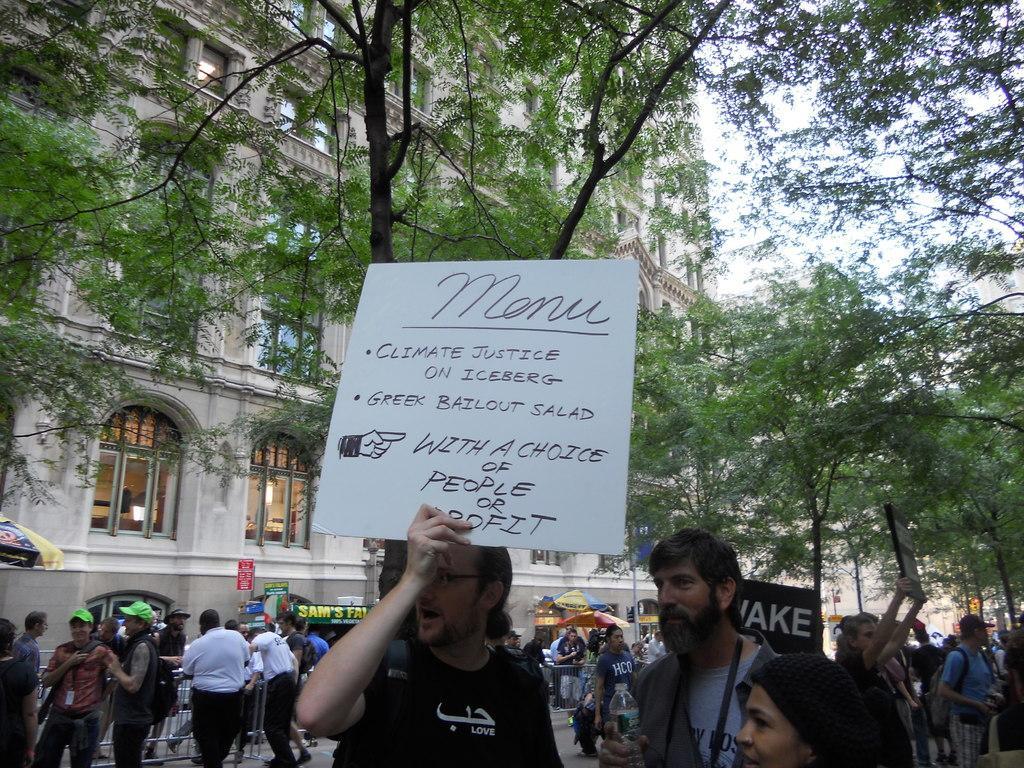How would you summarize this image in a sentence or two? In this picture there are people, among them two persons holding boards. We can see patio umbrellas, trees, barricades, boards and building. In the background of the image we can see the sky. 